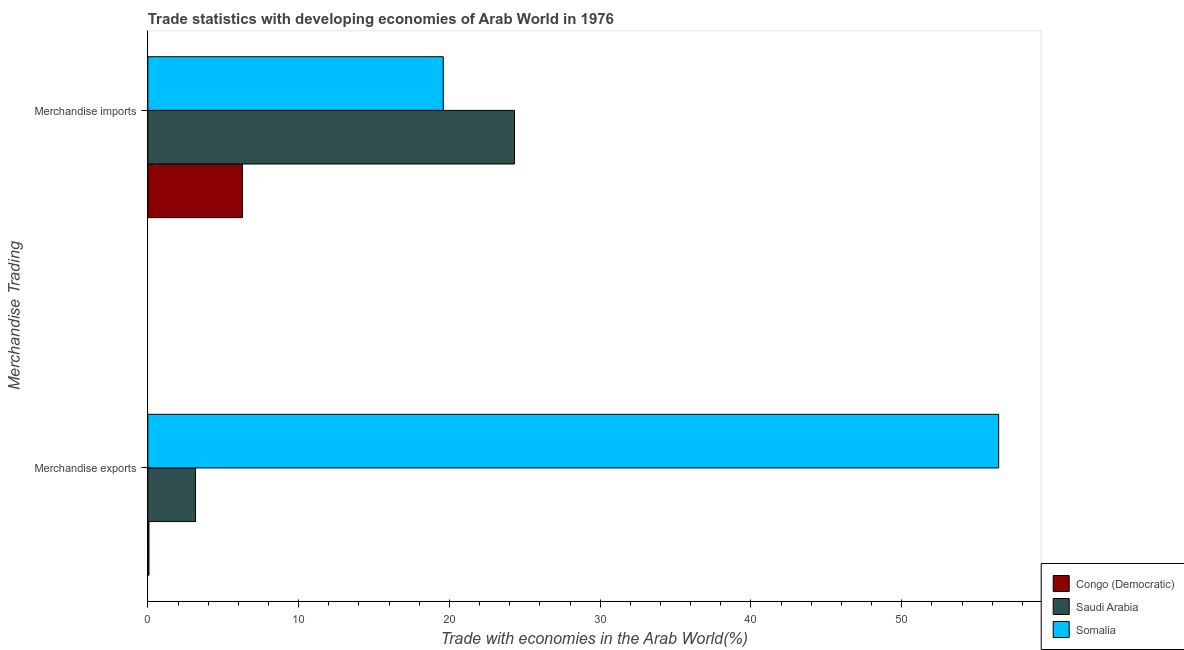How many different coloured bars are there?
Provide a short and direct response. 3. How many groups of bars are there?
Your response must be concise. 2. Are the number of bars per tick equal to the number of legend labels?
Your answer should be very brief. Yes. Are the number of bars on each tick of the Y-axis equal?
Your answer should be very brief. Yes. How many bars are there on the 1st tick from the top?
Make the answer very short. 3. How many bars are there on the 1st tick from the bottom?
Give a very brief answer. 3. What is the label of the 1st group of bars from the top?
Keep it short and to the point. Merchandise imports. What is the merchandise exports in Somalia?
Your response must be concise. 56.43. Across all countries, what is the maximum merchandise exports?
Keep it short and to the point. 56.43. Across all countries, what is the minimum merchandise exports?
Keep it short and to the point. 0.07. In which country was the merchandise exports maximum?
Make the answer very short. Somalia. In which country was the merchandise imports minimum?
Keep it short and to the point. Congo (Democratic). What is the total merchandise imports in the graph?
Your answer should be very brief. 50.18. What is the difference between the merchandise imports in Congo (Democratic) and that in Somalia?
Give a very brief answer. -13.32. What is the difference between the merchandise exports in Congo (Democratic) and the merchandise imports in Saudi Arabia?
Offer a very short reply. -24.24. What is the average merchandise exports per country?
Give a very brief answer. 19.89. What is the difference between the merchandise exports and merchandise imports in Saudi Arabia?
Make the answer very short. -21.15. In how many countries, is the merchandise exports greater than 26 %?
Give a very brief answer. 1. What is the ratio of the merchandise imports in Saudi Arabia to that in Somalia?
Your answer should be very brief. 1.24. In how many countries, is the merchandise exports greater than the average merchandise exports taken over all countries?
Give a very brief answer. 1. What does the 1st bar from the top in Merchandise exports represents?
Ensure brevity in your answer.  Somalia. What does the 3rd bar from the bottom in Merchandise imports represents?
Make the answer very short. Somalia. Are all the bars in the graph horizontal?
Keep it short and to the point. Yes. What is the difference between two consecutive major ticks on the X-axis?
Your response must be concise. 10. Does the graph contain any zero values?
Offer a very short reply. No. Where does the legend appear in the graph?
Your response must be concise. Bottom right. What is the title of the graph?
Provide a short and direct response. Trade statistics with developing economies of Arab World in 1976. What is the label or title of the X-axis?
Offer a very short reply. Trade with economies in the Arab World(%). What is the label or title of the Y-axis?
Offer a terse response. Merchandise Trading. What is the Trade with economies in the Arab World(%) of Congo (Democratic) in Merchandise exports?
Your response must be concise. 0.07. What is the Trade with economies in the Arab World(%) of Saudi Arabia in Merchandise exports?
Provide a succinct answer. 3.16. What is the Trade with economies in the Arab World(%) in Somalia in Merchandise exports?
Your answer should be very brief. 56.43. What is the Trade with economies in the Arab World(%) in Congo (Democratic) in Merchandise imports?
Make the answer very short. 6.27. What is the Trade with economies in the Arab World(%) of Saudi Arabia in Merchandise imports?
Provide a short and direct response. 24.32. What is the Trade with economies in the Arab World(%) of Somalia in Merchandise imports?
Ensure brevity in your answer.  19.59. Across all Merchandise Trading, what is the maximum Trade with economies in the Arab World(%) in Congo (Democratic)?
Offer a very short reply. 6.27. Across all Merchandise Trading, what is the maximum Trade with economies in the Arab World(%) of Saudi Arabia?
Provide a succinct answer. 24.32. Across all Merchandise Trading, what is the maximum Trade with economies in the Arab World(%) in Somalia?
Make the answer very short. 56.43. Across all Merchandise Trading, what is the minimum Trade with economies in the Arab World(%) in Congo (Democratic)?
Give a very brief answer. 0.07. Across all Merchandise Trading, what is the minimum Trade with economies in the Arab World(%) in Saudi Arabia?
Offer a very short reply. 3.16. Across all Merchandise Trading, what is the minimum Trade with economies in the Arab World(%) of Somalia?
Offer a very short reply. 19.59. What is the total Trade with economies in the Arab World(%) in Congo (Democratic) in the graph?
Provide a short and direct response. 6.35. What is the total Trade with economies in the Arab World(%) of Saudi Arabia in the graph?
Ensure brevity in your answer.  27.48. What is the total Trade with economies in the Arab World(%) of Somalia in the graph?
Offer a very short reply. 76.02. What is the difference between the Trade with economies in the Arab World(%) of Congo (Democratic) in Merchandise exports and that in Merchandise imports?
Your response must be concise. -6.2. What is the difference between the Trade with economies in the Arab World(%) of Saudi Arabia in Merchandise exports and that in Merchandise imports?
Make the answer very short. -21.15. What is the difference between the Trade with economies in the Arab World(%) of Somalia in Merchandise exports and that in Merchandise imports?
Provide a succinct answer. 36.84. What is the difference between the Trade with economies in the Arab World(%) of Congo (Democratic) in Merchandise exports and the Trade with economies in the Arab World(%) of Saudi Arabia in Merchandise imports?
Make the answer very short. -24.24. What is the difference between the Trade with economies in the Arab World(%) in Congo (Democratic) in Merchandise exports and the Trade with economies in the Arab World(%) in Somalia in Merchandise imports?
Offer a terse response. -19.52. What is the difference between the Trade with economies in the Arab World(%) in Saudi Arabia in Merchandise exports and the Trade with economies in the Arab World(%) in Somalia in Merchandise imports?
Provide a succinct answer. -16.43. What is the average Trade with economies in the Arab World(%) in Congo (Democratic) per Merchandise Trading?
Keep it short and to the point. 3.17. What is the average Trade with economies in the Arab World(%) in Saudi Arabia per Merchandise Trading?
Keep it short and to the point. 13.74. What is the average Trade with economies in the Arab World(%) of Somalia per Merchandise Trading?
Keep it short and to the point. 38.01. What is the difference between the Trade with economies in the Arab World(%) in Congo (Democratic) and Trade with economies in the Arab World(%) in Saudi Arabia in Merchandise exports?
Offer a very short reply. -3.09. What is the difference between the Trade with economies in the Arab World(%) in Congo (Democratic) and Trade with economies in the Arab World(%) in Somalia in Merchandise exports?
Your answer should be compact. -56.35. What is the difference between the Trade with economies in the Arab World(%) of Saudi Arabia and Trade with economies in the Arab World(%) of Somalia in Merchandise exports?
Your answer should be very brief. -53.26. What is the difference between the Trade with economies in the Arab World(%) in Congo (Democratic) and Trade with economies in the Arab World(%) in Saudi Arabia in Merchandise imports?
Give a very brief answer. -18.04. What is the difference between the Trade with economies in the Arab World(%) of Congo (Democratic) and Trade with economies in the Arab World(%) of Somalia in Merchandise imports?
Offer a very short reply. -13.32. What is the difference between the Trade with economies in the Arab World(%) of Saudi Arabia and Trade with economies in the Arab World(%) of Somalia in Merchandise imports?
Offer a terse response. 4.72. What is the ratio of the Trade with economies in the Arab World(%) of Congo (Democratic) in Merchandise exports to that in Merchandise imports?
Your answer should be compact. 0.01. What is the ratio of the Trade with economies in the Arab World(%) in Saudi Arabia in Merchandise exports to that in Merchandise imports?
Your response must be concise. 0.13. What is the ratio of the Trade with economies in the Arab World(%) in Somalia in Merchandise exports to that in Merchandise imports?
Make the answer very short. 2.88. What is the difference between the highest and the second highest Trade with economies in the Arab World(%) in Congo (Democratic)?
Provide a short and direct response. 6.2. What is the difference between the highest and the second highest Trade with economies in the Arab World(%) of Saudi Arabia?
Keep it short and to the point. 21.15. What is the difference between the highest and the second highest Trade with economies in the Arab World(%) of Somalia?
Give a very brief answer. 36.84. What is the difference between the highest and the lowest Trade with economies in the Arab World(%) in Congo (Democratic)?
Your response must be concise. 6.2. What is the difference between the highest and the lowest Trade with economies in the Arab World(%) of Saudi Arabia?
Make the answer very short. 21.15. What is the difference between the highest and the lowest Trade with economies in the Arab World(%) in Somalia?
Keep it short and to the point. 36.84. 